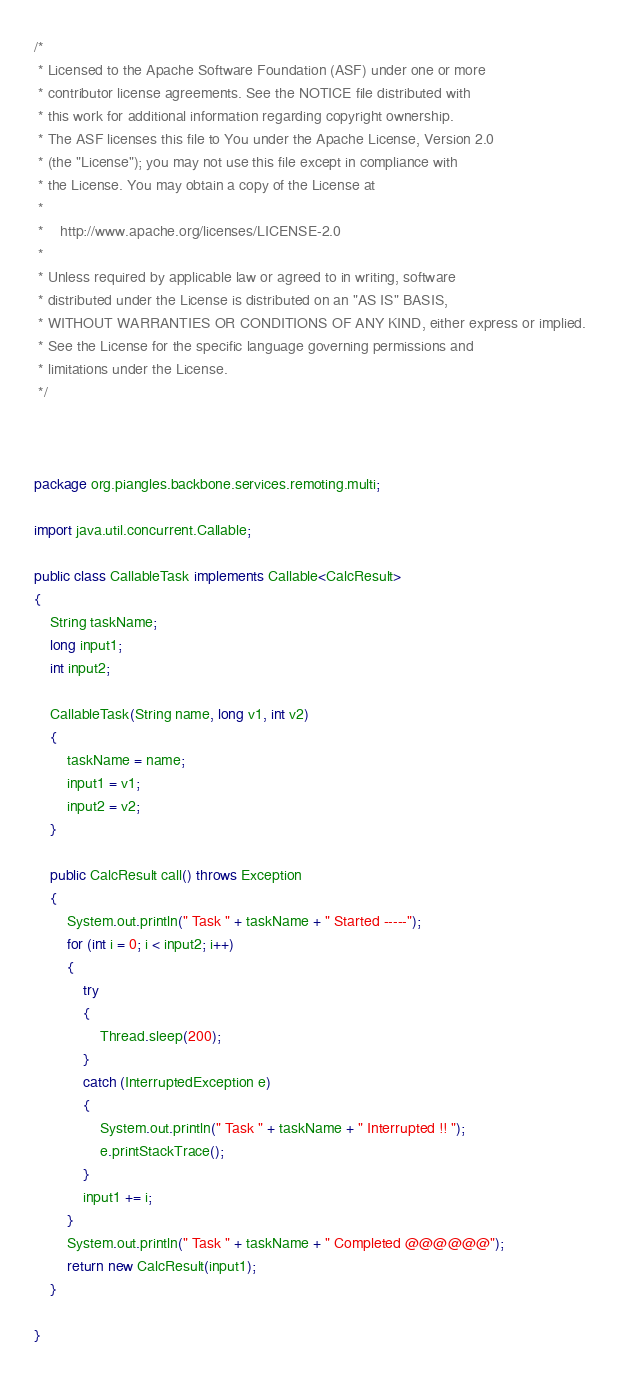<code> <loc_0><loc_0><loc_500><loc_500><_Java_>/*
 * Licensed to the Apache Software Foundation (ASF) under one or more
 * contributor license agreements. See the NOTICE file distributed with
 * this work for additional information regarding copyright ownership.
 * The ASF licenses this file to You under the Apache License, Version 2.0
 * (the "License"); you may not use this file except in compliance with
 * the License. You may obtain a copy of the License at
 *
 *    http://www.apache.org/licenses/LICENSE-2.0
 *
 * Unless required by applicable law or agreed to in writing, software
 * distributed under the License is distributed on an "AS IS" BASIS,
 * WITHOUT WARRANTIES OR CONDITIONS OF ANY KIND, either express or implied.
 * See the License for the specific language governing permissions and
 * limitations under the License.
 */
 
 
 
package org.piangles.backbone.services.remoting.multi;

import java.util.concurrent.Callable;

public class CallableTask implements Callable<CalcResult>
{
	String taskName;
	long input1;
	int input2;

	CallableTask(String name, long v1, int v2)
	{
		taskName = name;
		input1 = v1;
		input2 = v2;
	}

	public CalcResult call() throws Exception
	{
		System.out.println(" Task " + taskName + " Started -----");
		for (int i = 0; i < input2; i++)
		{
			try
			{
				Thread.sleep(200);
			}
			catch (InterruptedException e)
			{
				System.out.println(" Task " + taskName + " Interrupted !! ");
				e.printStackTrace();
			}
			input1 += i;
		}
		System.out.println(" Task " + taskName + " Completed @@@@@@");
		return new CalcResult(input1);
	}

}
</code> 